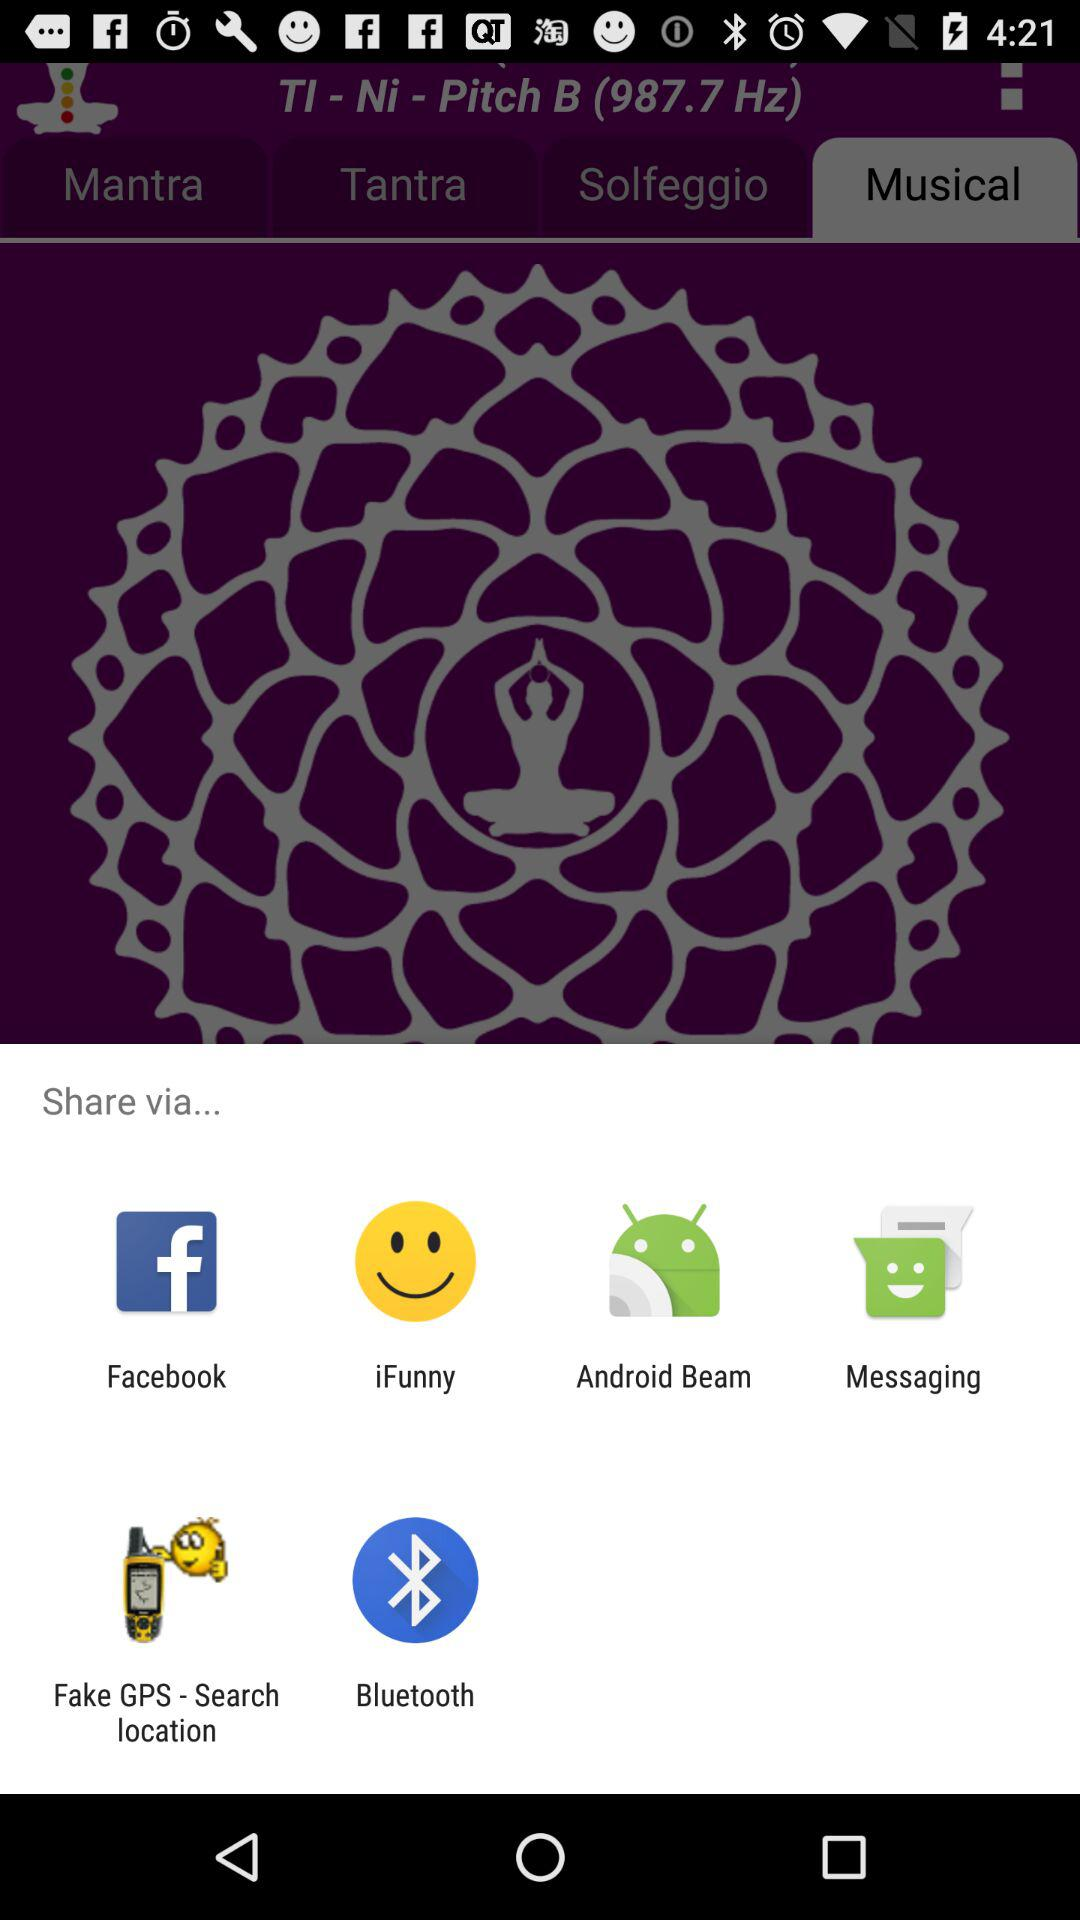What are the different options available for sharing? The different options available for sharing are "Facebook", "iFunny", "Android Beam", "Messaging", "Fake GPS - Search location" and "Bluetooth". 